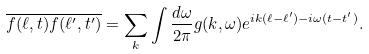<formula> <loc_0><loc_0><loc_500><loc_500>\overline { f ( \ell , t ) f ( \ell ^ { \prime } , t ^ { \prime } ) } = \sum _ { k } \int \frac { d \omega } { 2 \pi } g ( k , \omega ) e ^ { i k ( \ell - \ell ^ { \prime } ) - i \omega ( t - t ^ { \prime } ) } .</formula> 